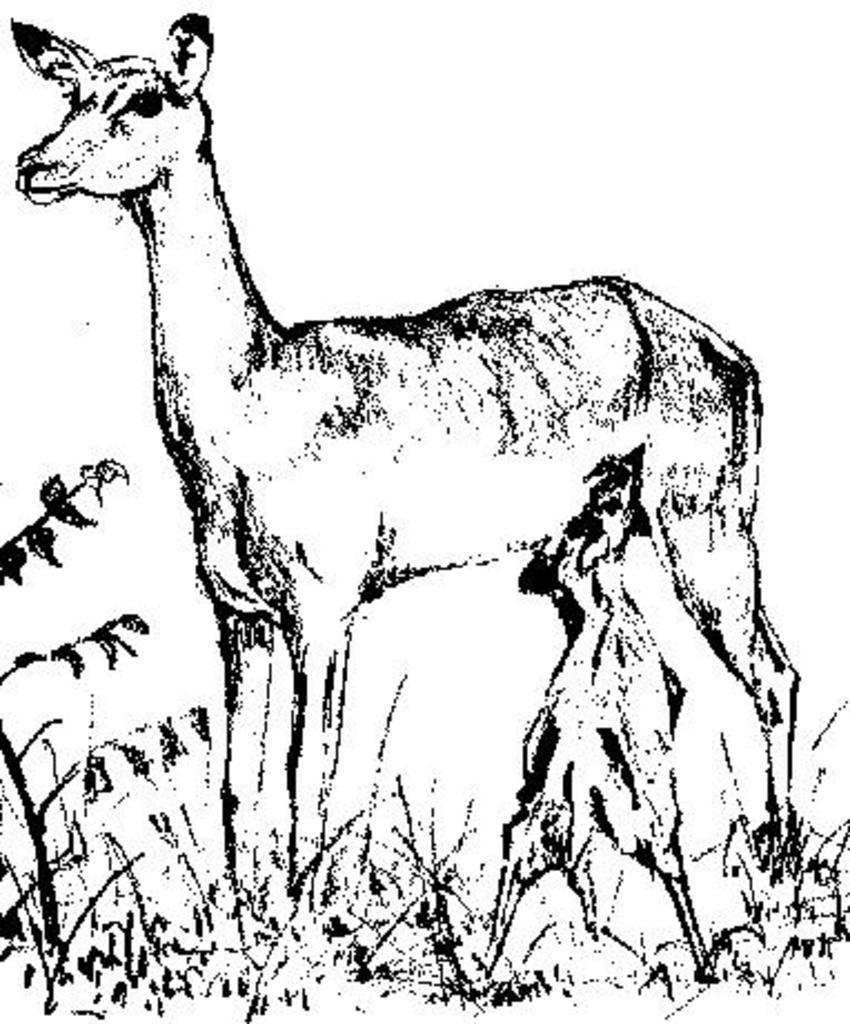Could you give a brief overview of what you see in this image? In the image there is a part of a deer feeding a calf on the grassland. 